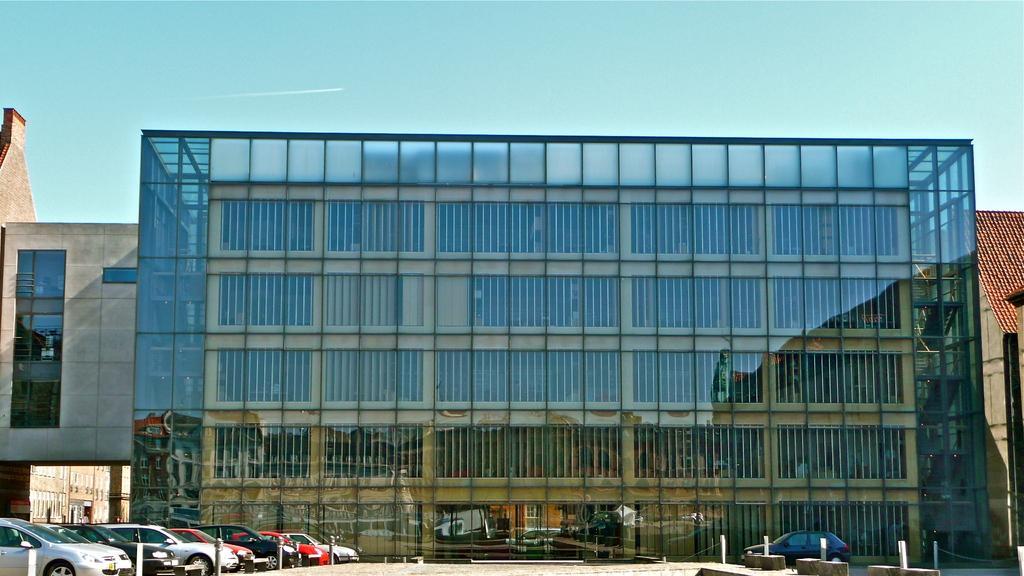Please provide a concise description of this image. In this image, we can see some cars in front of the building. There is a sky at the top of the image. 